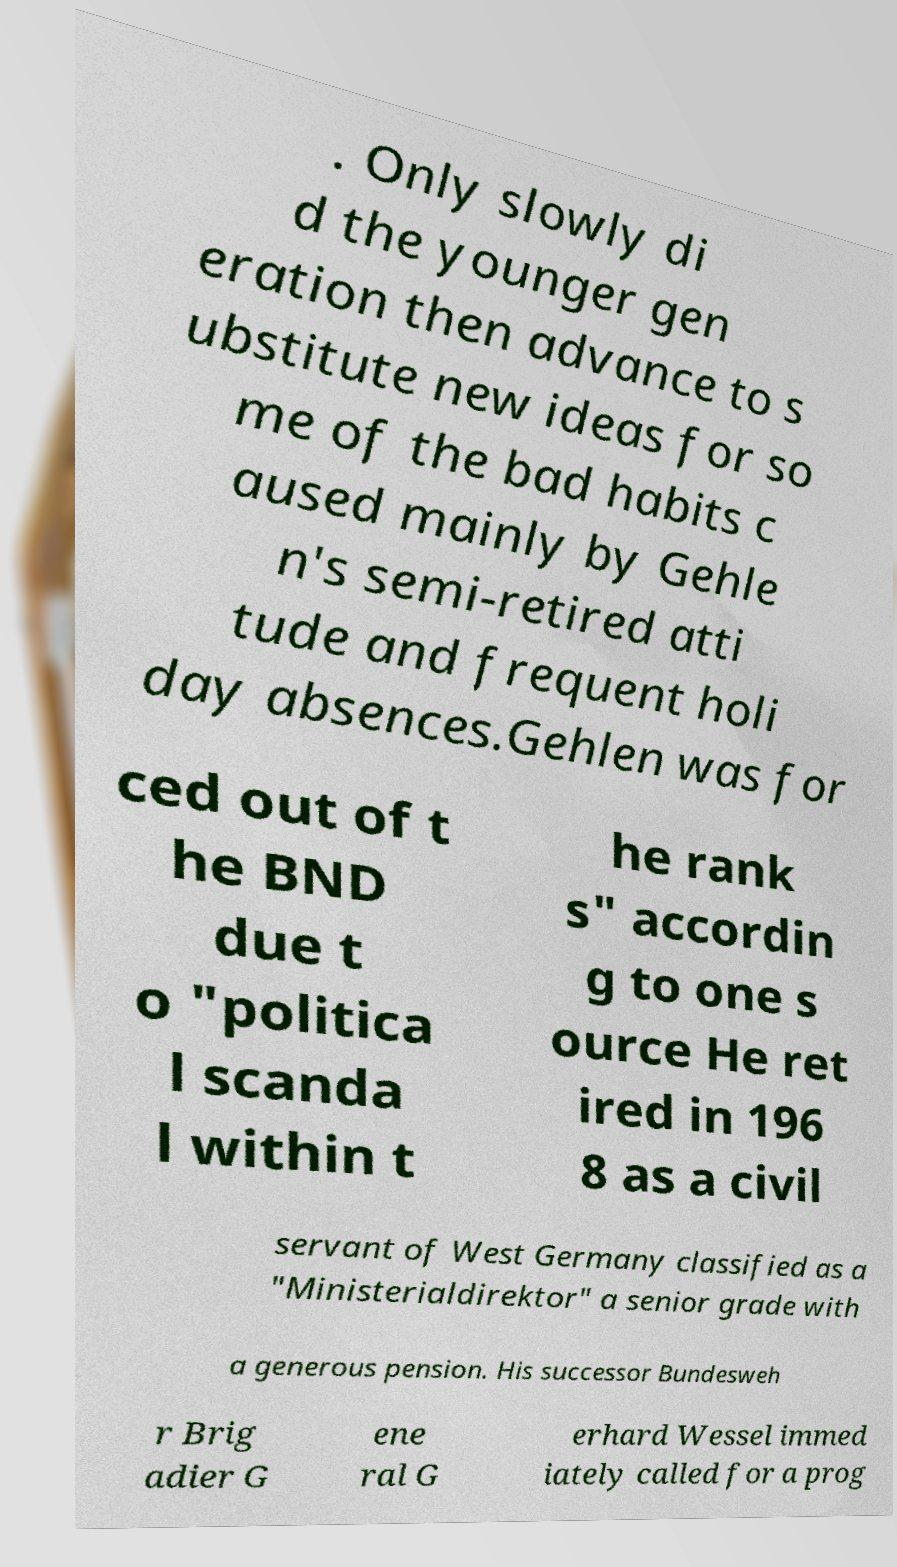Can you accurately transcribe the text from the provided image for me? . Only slowly di d the younger gen eration then advance to s ubstitute new ideas for so me of the bad habits c aused mainly by Gehle n's semi-retired atti tude and frequent holi day absences.Gehlen was for ced out of t he BND due t o "politica l scanda l within t he rank s" accordin g to one s ource He ret ired in 196 8 as a civil servant of West Germany classified as a "Ministerialdirektor" a senior grade with a generous pension. His successor Bundesweh r Brig adier G ene ral G erhard Wessel immed iately called for a prog 